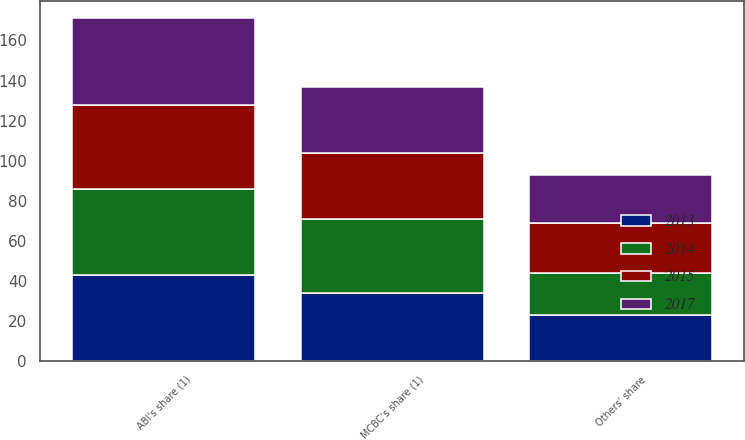Convert chart to OTSL. <chart><loc_0><loc_0><loc_500><loc_500><stacked_bar_chart><ecel><fcel>MCBC's share (1)<fcel>ABI's share (1)<fcel>Others' share<nl><fcel>2015<fcel>33<fcel>42<fcel>25<nl><fcel>2017<fcel>33<fcel>43<fcel>24<nl><fcel>2013<fcel>34<fcel>43<fcel>23<nl><fcel>2014<fcel>37<fcel>43<fcel>21<nl></chart> 